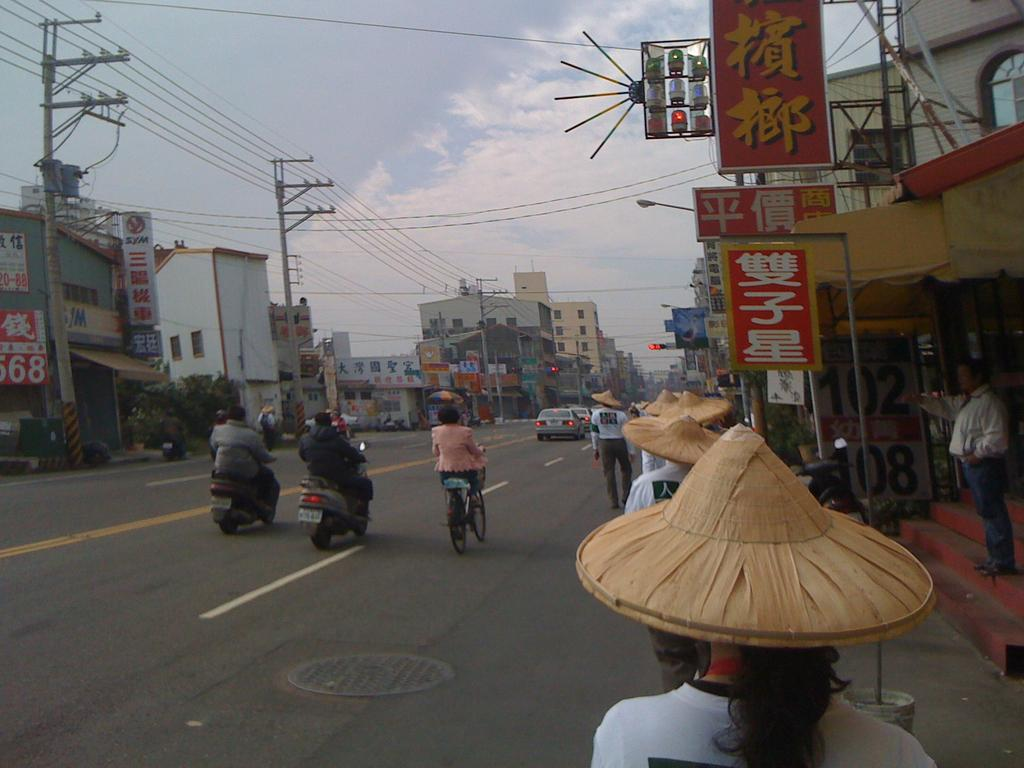<image>
Relay a brief, clear account of the picture shown. some Japanese writing that is on the stores near the street 